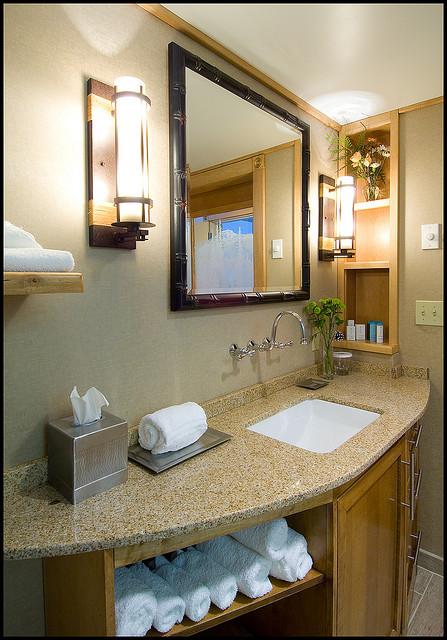What is stored in the open cabinetry?
Concise answer only. Towels. Could two people apply their makeup at the same time?
Answer briefly. Yes. How many mirrors are in the picture?
Give a very brief answer. 1. 